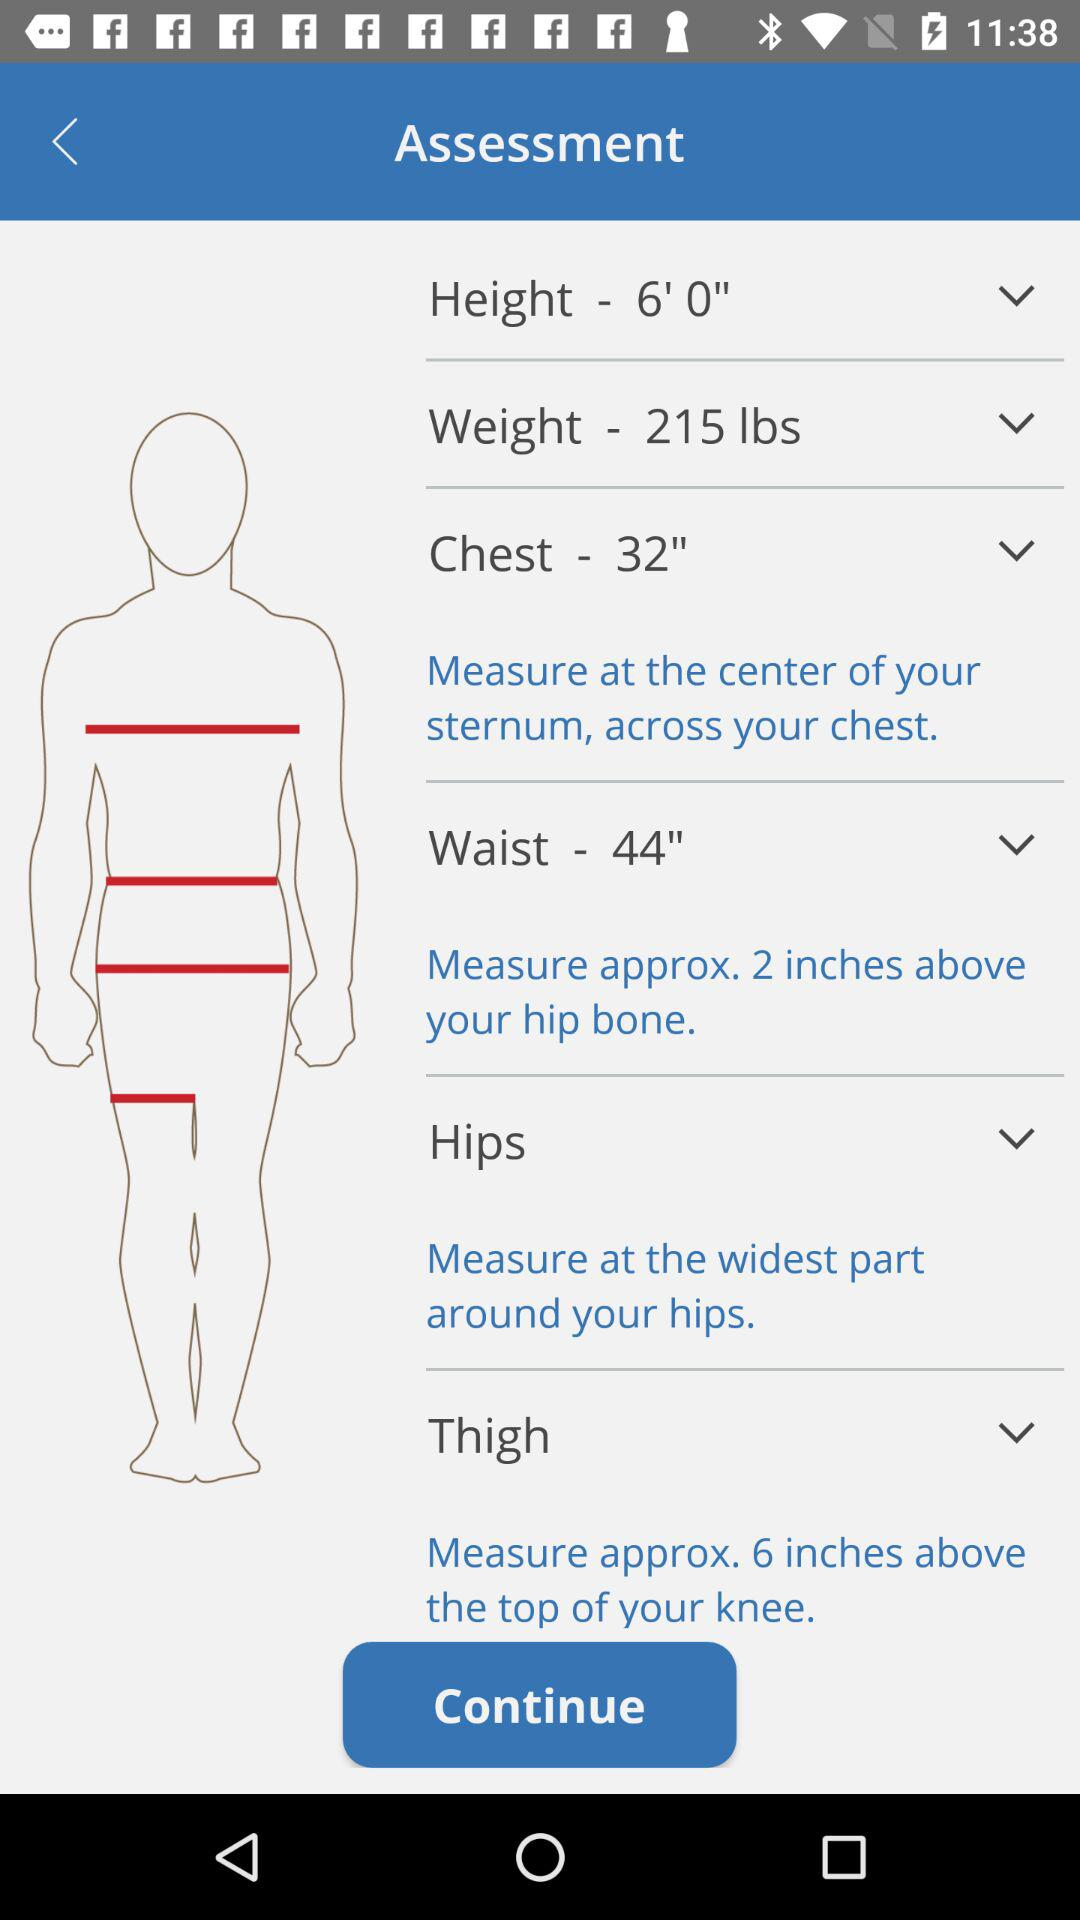What is the selected height? The selected height is 6 feet. 